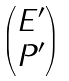<formula> <loc_0><loc_0><loc_500><loc_500>\begin{pmatrix} E ^ { \prime } \\ P ^ { \prime } \end{pmatrix}</formula> 